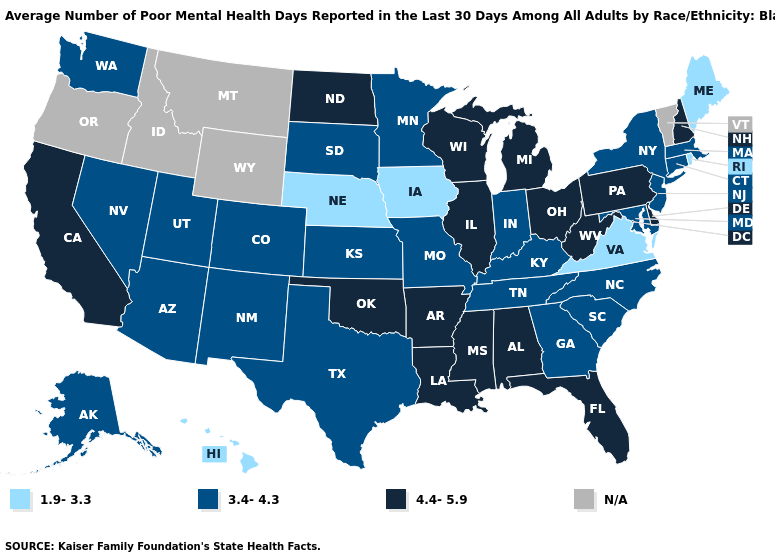How many symbols are there in the legend?
Keep it brief. 4. What is the value of Idaho?
Keep it brief. N/A. What is the value of Mississippi?
Give a very brief answer. 4.4-5.9. What is the lowest value in the USA?
Be succinct. 1.9-3.3. Name the states that have a value in the range 3.4-4.3?
Write a very short answer. Alaska, Arizona, Colorado, Connecticut, Georgia, Indiana, Kansas, Kentucky, Maryland, Massachusetts, Minnesota, Missouri, Nevada, New Jersey, New Mexico, New York, North Carolina, South Carolina, South Dakota, Tennessee, Texas, Utah, Washington. Name the states that have a value in the range 3.4-4.3?
Keep it brief. Alaska, Arizona, Colorado, Connecticut, Georgia, Indiana, Kansas, Kentucky, Maryland, Massachusetts, Minnesota, Missouri, Nevada, New Jersey, New Mexico, New York, North Carolina, South Carolina, South Dakota, Tennessee, Texas, Utah, Washington. What is the value of Massachusetts?
Be succinct. 3.4-4.3. Name the states that have a value in the range N/A?
Keep it brief. Idaho, Montana, Oregon, Vermont, Wyoming. Does Virginia have the lowest value in the USA?
Give a very brief answer. Yes. Among the states that border Mississippi , does Tennessee have the lowest value?
Write a very short answer. Yes. Which states have the lowest value in the USA?
Quick response, please. Hawaii, Iowa, Maine, Nebraska, Rhode Island, Virginia. What is the highest value in the Northeast ?
Concise answer only. 4.4-5.9. Does the first symbol in the legend represent the smallest category?
Short answer required. Yes. Among the states that border Arkansas , which have the highest value?
Keep it brief. Louisiana, Mississippi, Oklahoma. 